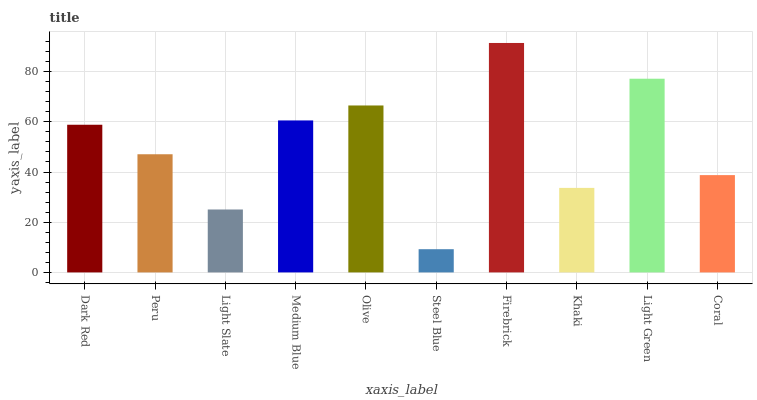Is Steel Blue the minimum?
Answer yes or no. Yes. Is Firebrick the maximum?
Answer yes or no. Yes. Is Peru the minimum?
Answer yes or no. No. Is Peru the maximum?
Answer yes or no. No. Is Dark Red greater than Peru?
Answer yes or no. Yes. Is Peru less than Dark Red?
Answer yes or no. Yes. Is Peru greater than Dark Red?
Answer yes or no. No. Is Dark Red less than Peru?
Answer yes or no. No. Is Dark Red the high median?
Answer yes or no. Yes. Is Peru the low median?
Answer yes or no. Yes. Is Firebrick the high median?
Answer yes or no. No. Is Light Slate the low median?
Answer yes or no. No. 